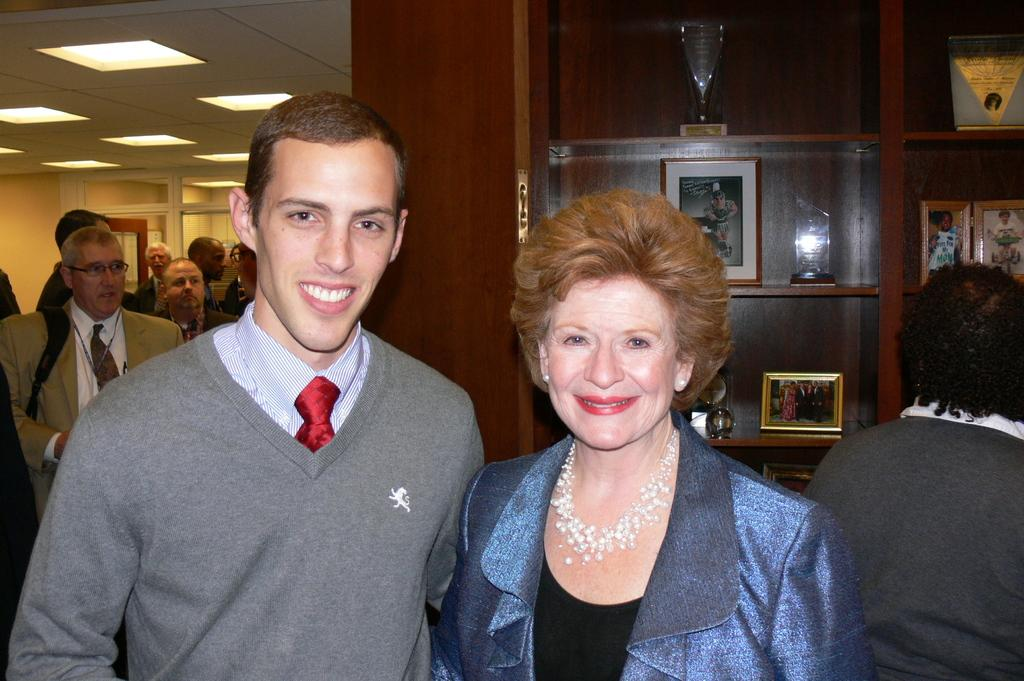How many people are in the foreground of the image? There are two persons standing in the center of the image. Can you describe the background of the image? There are additional persons in the background of the image. What is located on the shelf in the image? The facts do not specify the objects on the shelf, so we cannot answer this question definitively. What type of flower is being compared to the coal in the image? There is no flower or coal present in the image, so it is not possible to answer that question. 